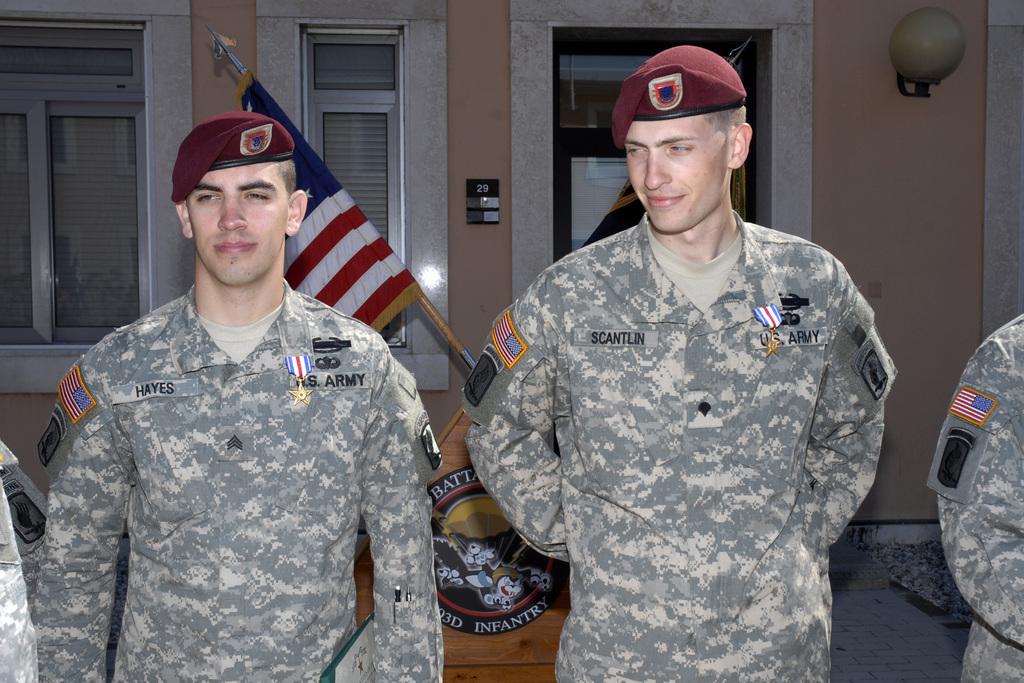What branch of military are these men in?
Offer a terse response. Army. What are the soldiers last name?
Offer a very short reply. Hayes and scantlin. 